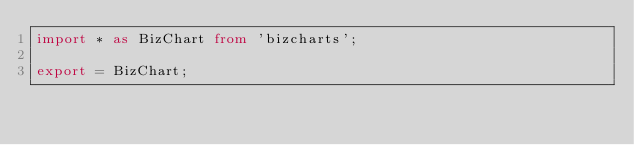Convert code to text. <code><loc_0><loc_0><loc_500><loc_500><_TypeScript_>import * as BizChart from 'bizcharts';

export = BizChart;
</code> 